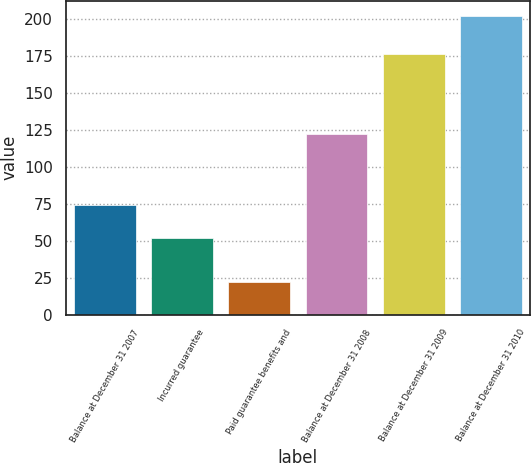<chart> <loc_0><loc_0><loc_500><loc_500><bar_chart><fcel>Balance at December 31 2007<fcel>Incurred guarantee<fcel>Paid guarantee benefits and<fcel>Balance at December 31 2008<fcel>Balance at December 31 2009<fcel>Balance at December 31 2010<nl><fcel>74<fcel>52<fcel>22<fcel>122<fcel>176<fcel>202<nl></chart> 